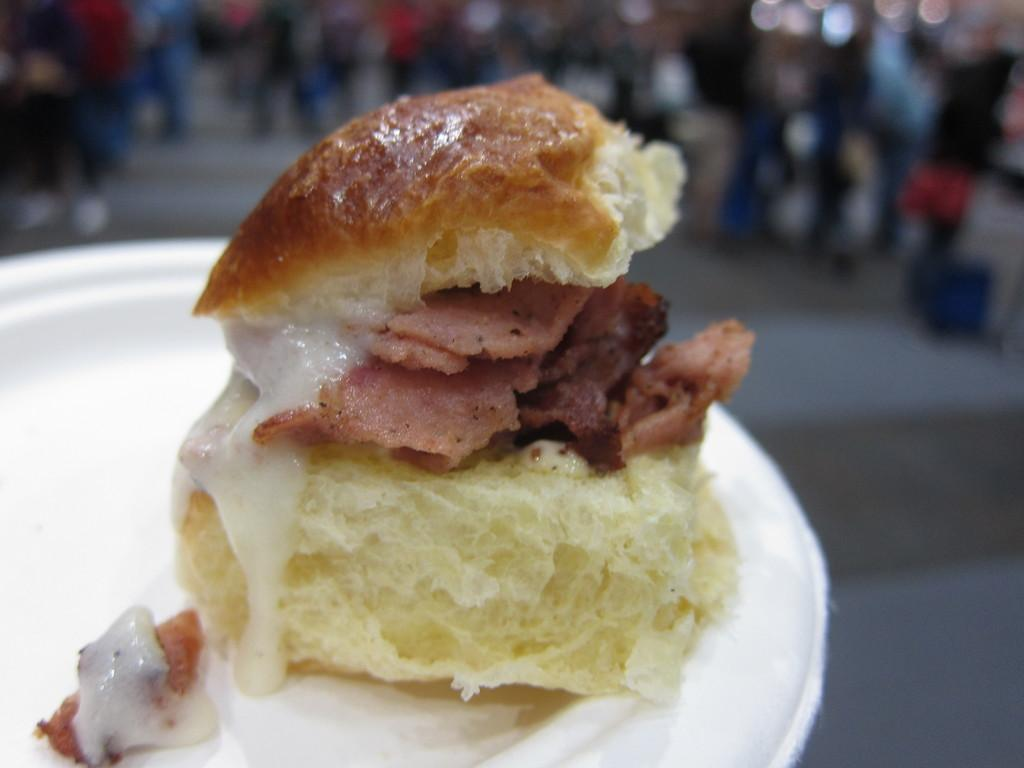What is the main subject in the foreground of the image? There is a sandwich in the foreground of the image. What type of topping is on the sandwich? The sandwich has cream on it. How is the sandwich presented in the image? The sandwich is placed on a white platter. Can you describe the background of the image? There are blurred persons in the background of the image. What type of jelly is visible on the collar of the person in the image? There is no jelly or person with a collar present in the image; the background features blurred persons. 